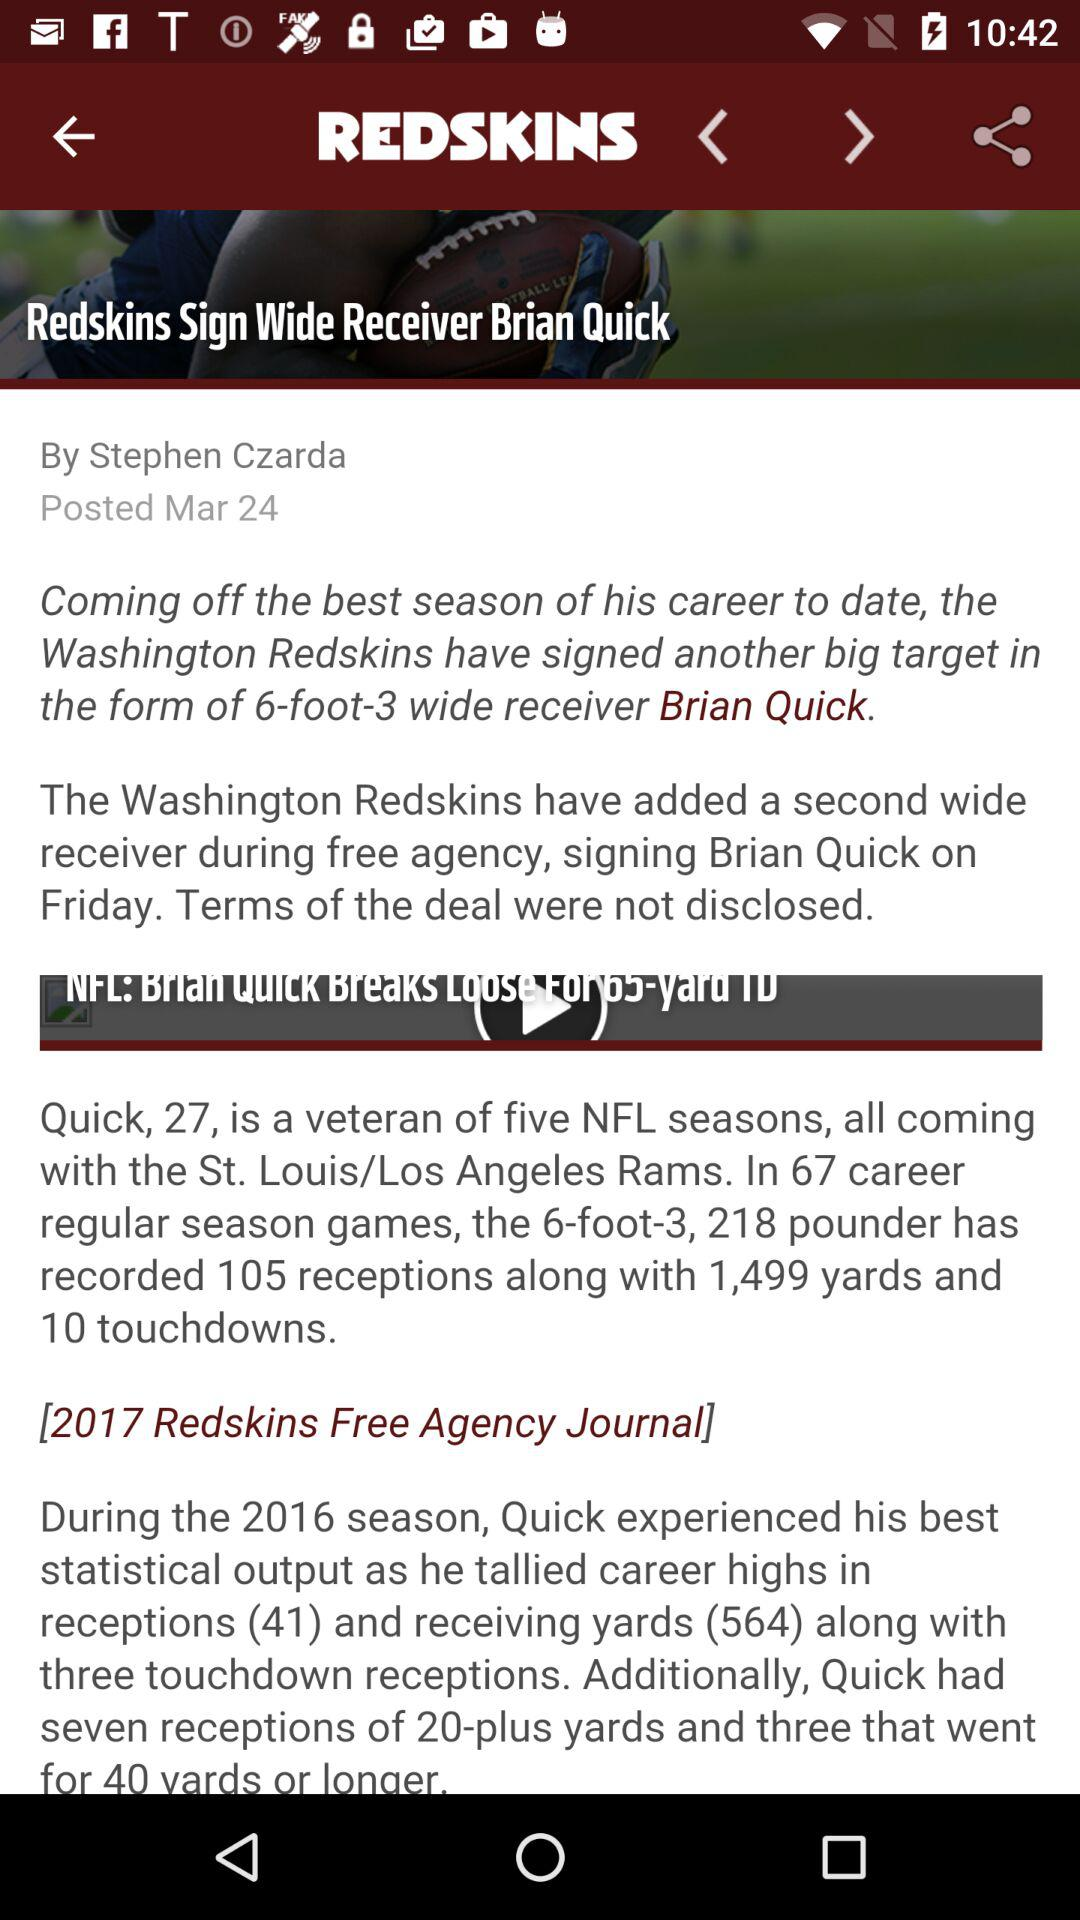What is the headline of the article? The headline of the article is "Redskins Sign Wide Receiver Brian Quick". 